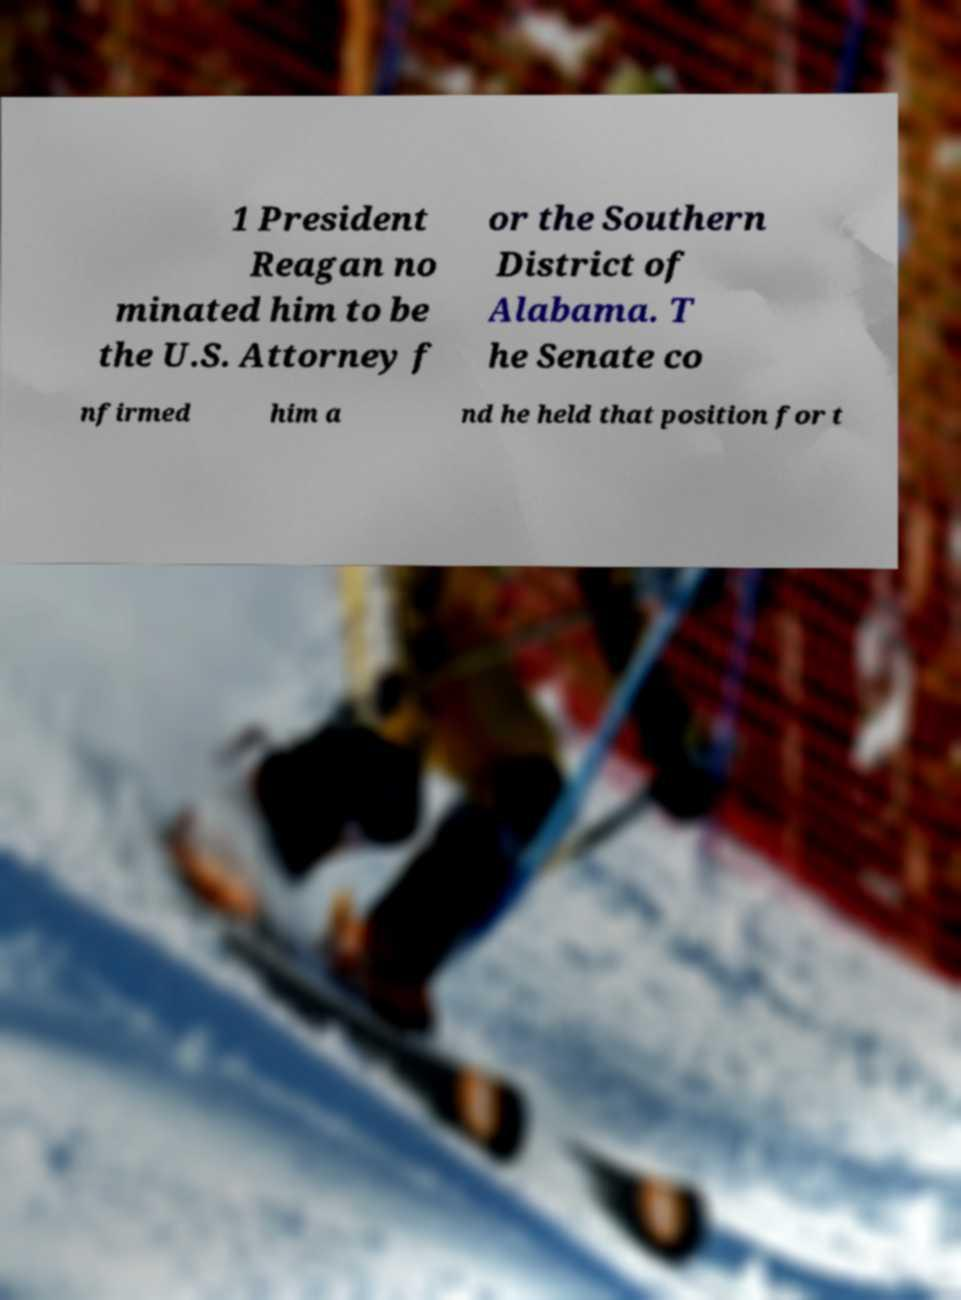For documentation purposes, I need the text within this image transcribed. Could you provide that? 1 President Reagan no minated him to be the U.S. Attorney f or the Southern District of Alabama. T he Senate co nfirmed him a nd he held that position for t 